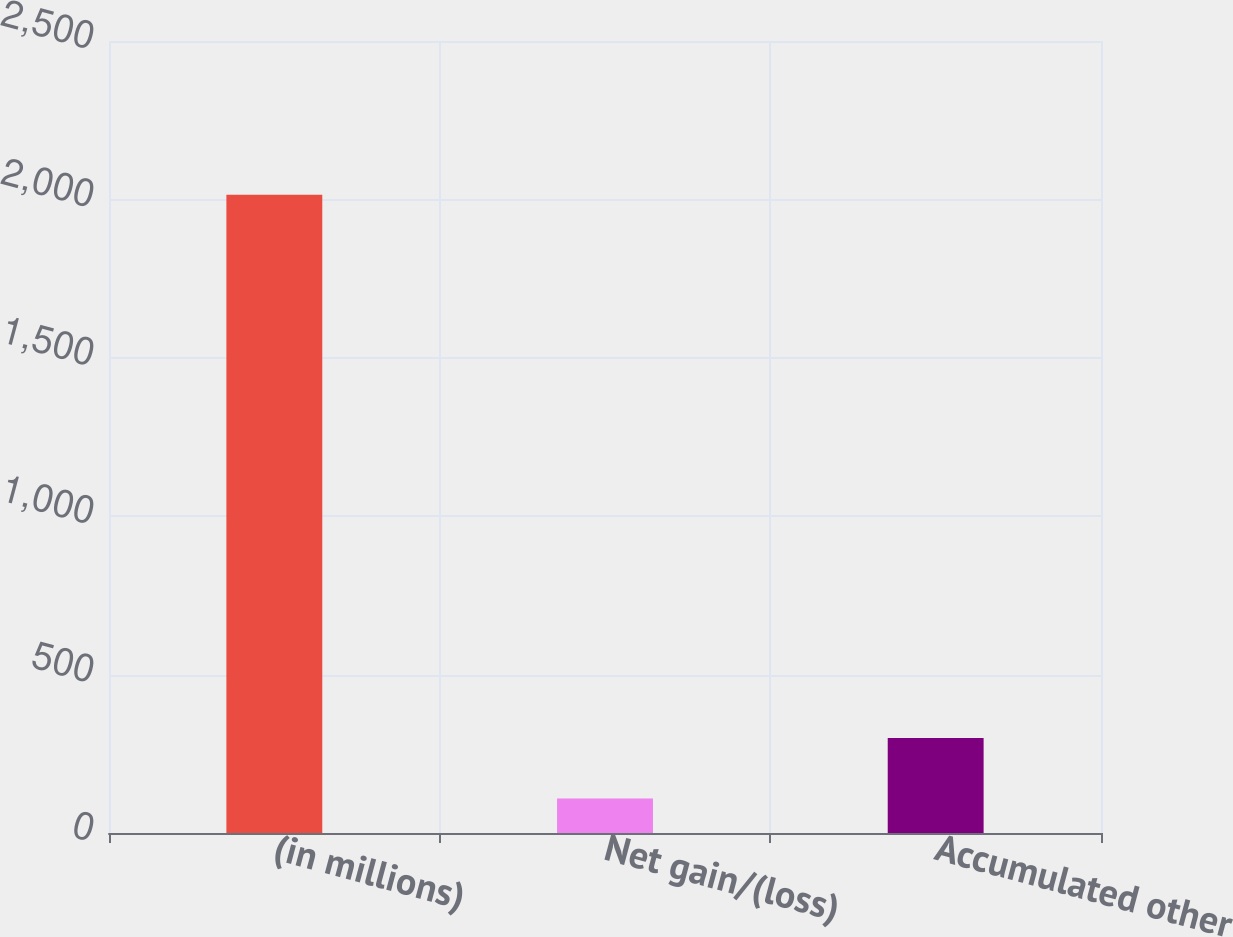<chart> <loc_0><loc_0><loc_500><loc_500><bar_chart><fcel>(in millions)<fcel>Net gain/(loss)<fcel>Accumulated other<nl><fcel>2015<fcel>109<fcel>299.6<nl></chart> 